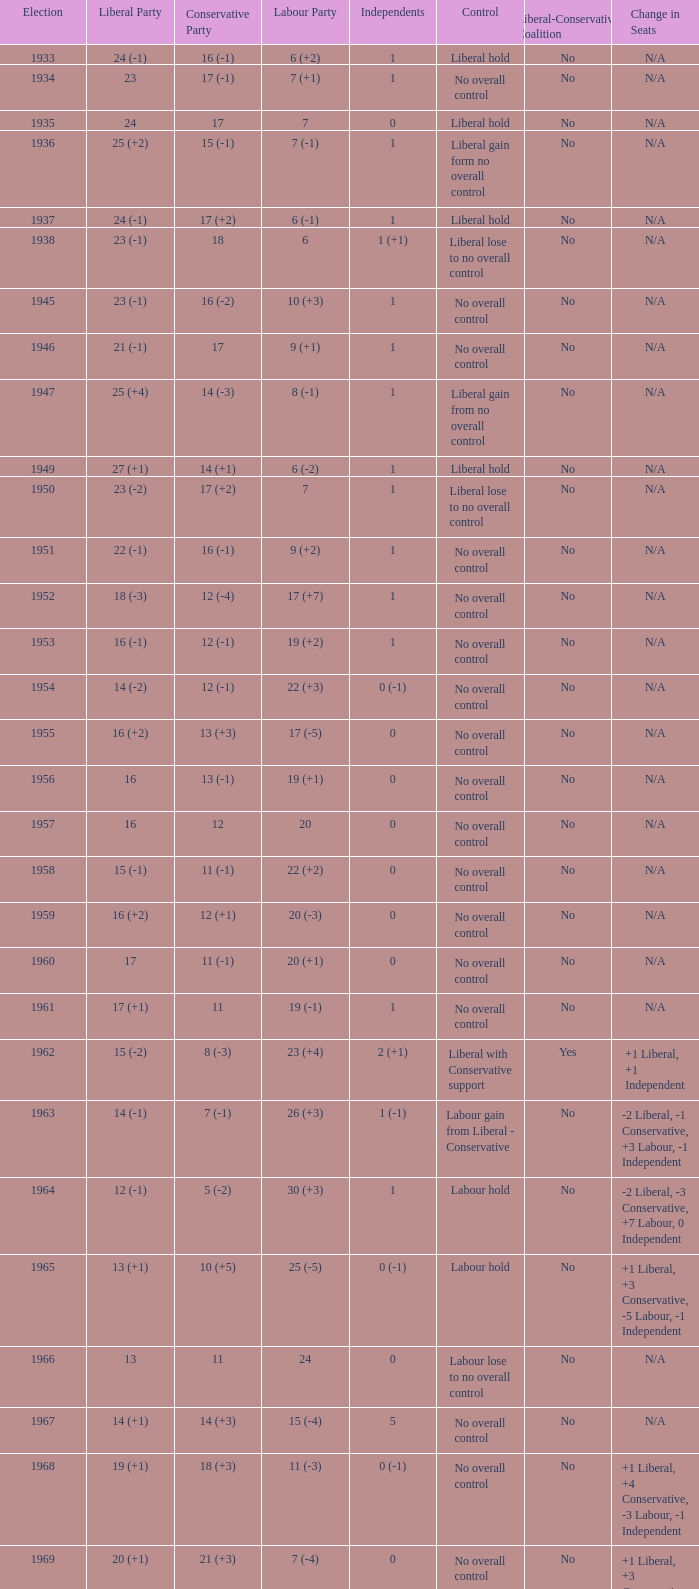Who was in control the year that Labour Party won 12 (+6) seats? No overall control (1 vacancy). 